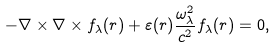<formula> <loc_0><loc_0><loc_500><loc_500>- \nabla \times \nabla \times { f } _ { \lambda } ( { r } ) + \varepsilon ( { r } ) \frac { \omega _ { \lambda } ^ { 2 } } { c ^ { 2 } } { f } _ { \lambda } ( { r } ) = 0 ,</formula> 